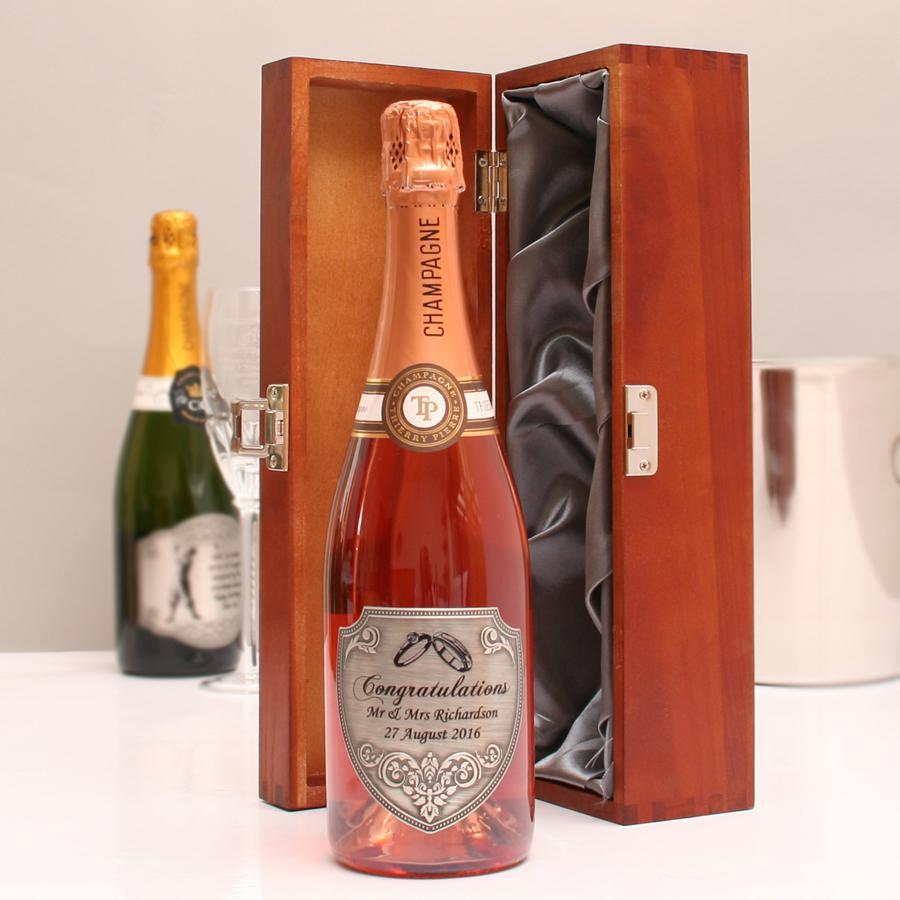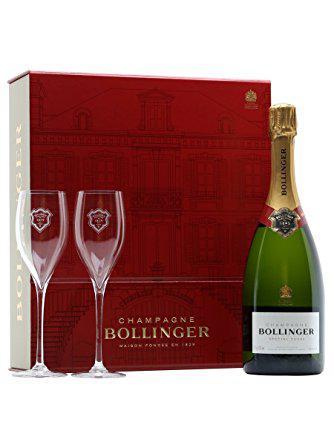The first image is the image on the left, the second image is the image on the right. Given the left and right images, does the statement "Two glasses have champagne in them." hold true? Answer yes or no. No. 